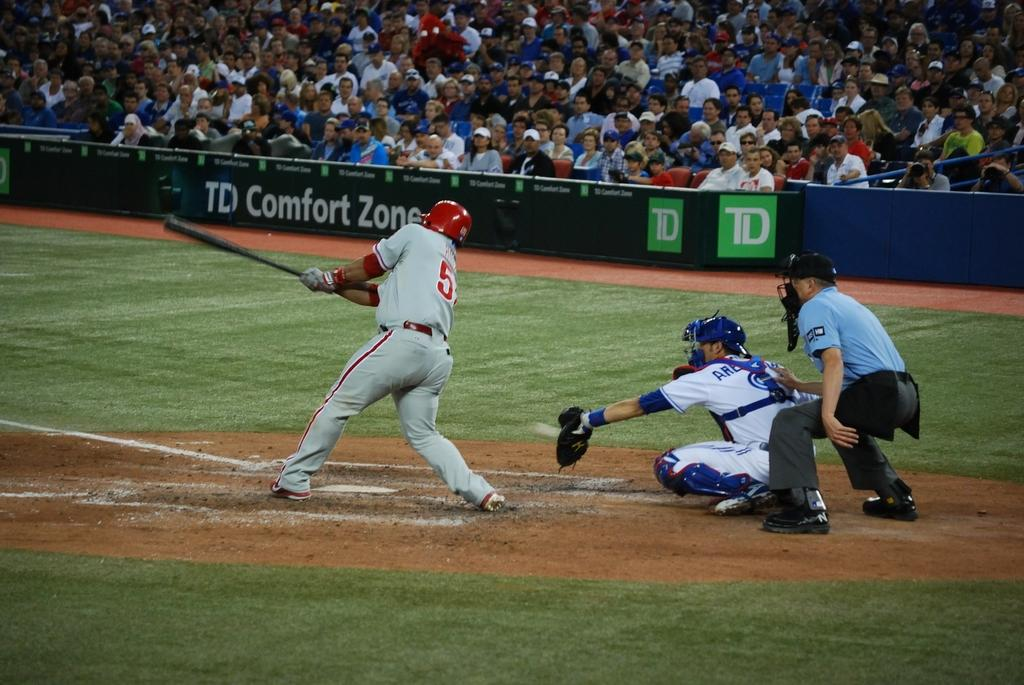<image>
Summarize the visual content of the image. A baseball player is swinging for the ball and an ad for TD Comfort Zone is on the stadium while. 